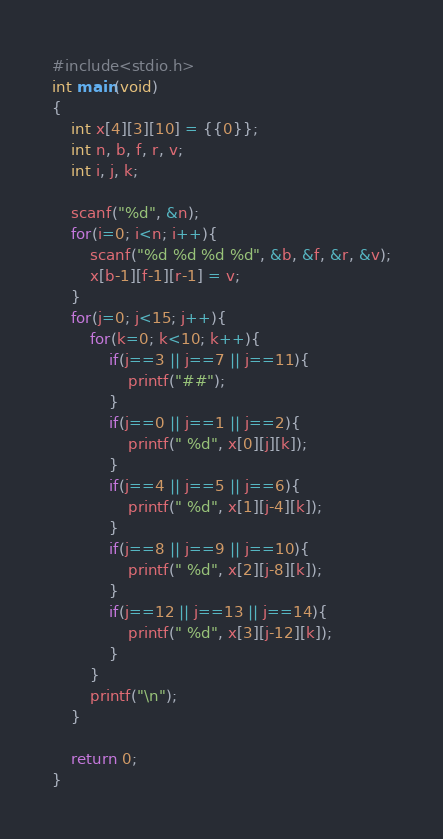<code> <loc_0><loc_0><loc_500><loc_500><_C_>#include<stdio.h>
int main(void)
{
	int x[4][3][10] = {{0}};
	int n, b, f, r, v;
	int i, j, k;
	
	scanf("%d", &n);
	for(i=0; i<n; i++){
		scanf("%d %d %d %d", &b, &f, &r, &v);
		x[b-1][f-1][r-1] = v;
	}
	for(j=0; j<15; j++){
		for(k=0; k<10; k++){
			if(j==3 || j==7 || j==11){
				printf("##");
			}
			if(j==0 || j==1 || j==2){
				printf(" %d", x[0][j][k]);
			}
			if(j==4 || j==5 || j==6){
				printf(" %d", x[1][j-4][k]);
			}
			if(j==8 || j==9 || j==10){
				printf(" %d", x[2][j-8][k]);
			}
			if(j==12 || j==13 || j==14){
				printf(" %d", x[3][j-12][k]);
			}
		}
		printf("\n");
	}
	
	return 0;
}</code> 